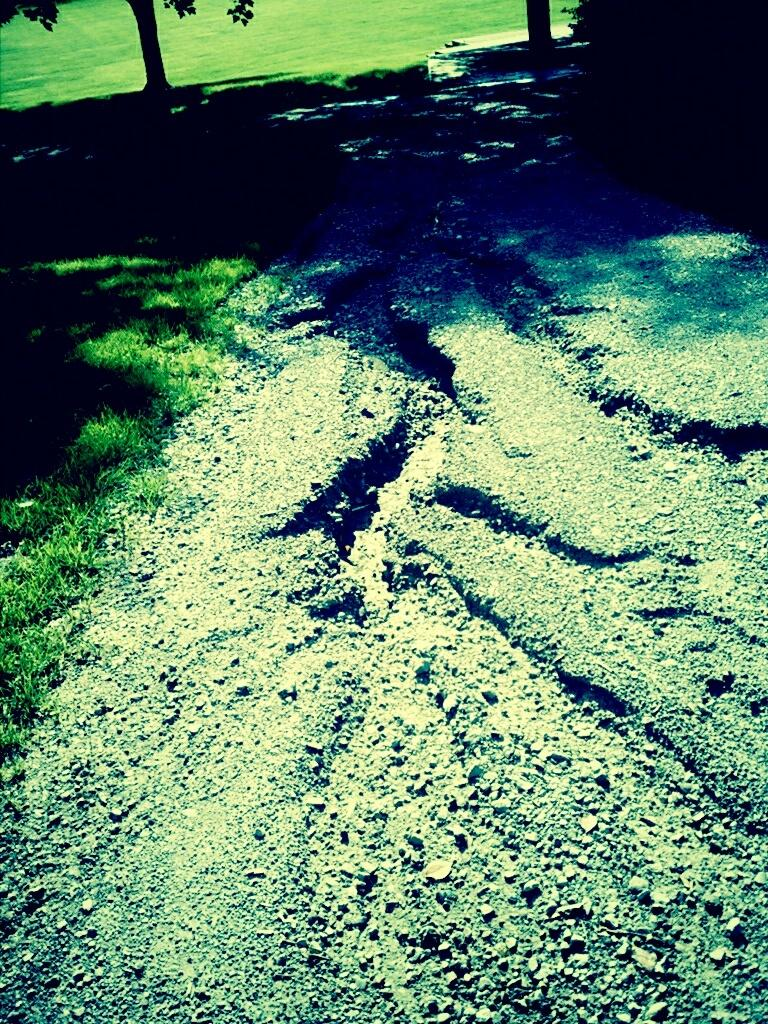What is the main feature of the image? There is a cracked path in the image. What type of surface is next to the cracked path? There is a grass surface beside the path. How many trees can be seen in the background of the image? There are two trees in the background of the image. What is the extent of the grass surface in the image? The grass surface extends into the background. What type of work is the doctor performing on the cracked path in the image? There is no doctor or any work being performed on the cracked path in the image. Is there any sleet visible in the image? There is no mention of sleet or any weather condition in the image; it only shows a cracked path, grass surface, and trees. 